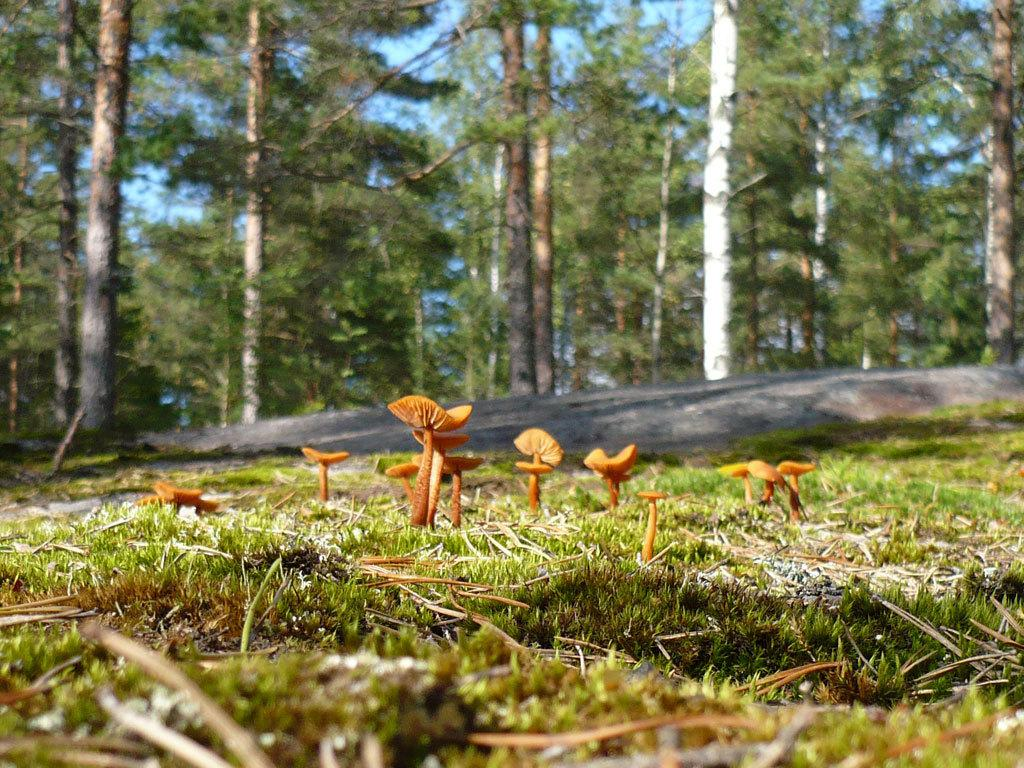What type of vegetation can be seen in the image? There are trees and grass in the image. Are there any other natural elements present in the image? Yes, there are mushrooms in the image. What can be seen in the background of the image? The sky is visible in the image. What type of guitar can be seen in the image? There is no guitar present in the image. What color is the ink on the fan in the image? There is no fan or ink present in the image. 